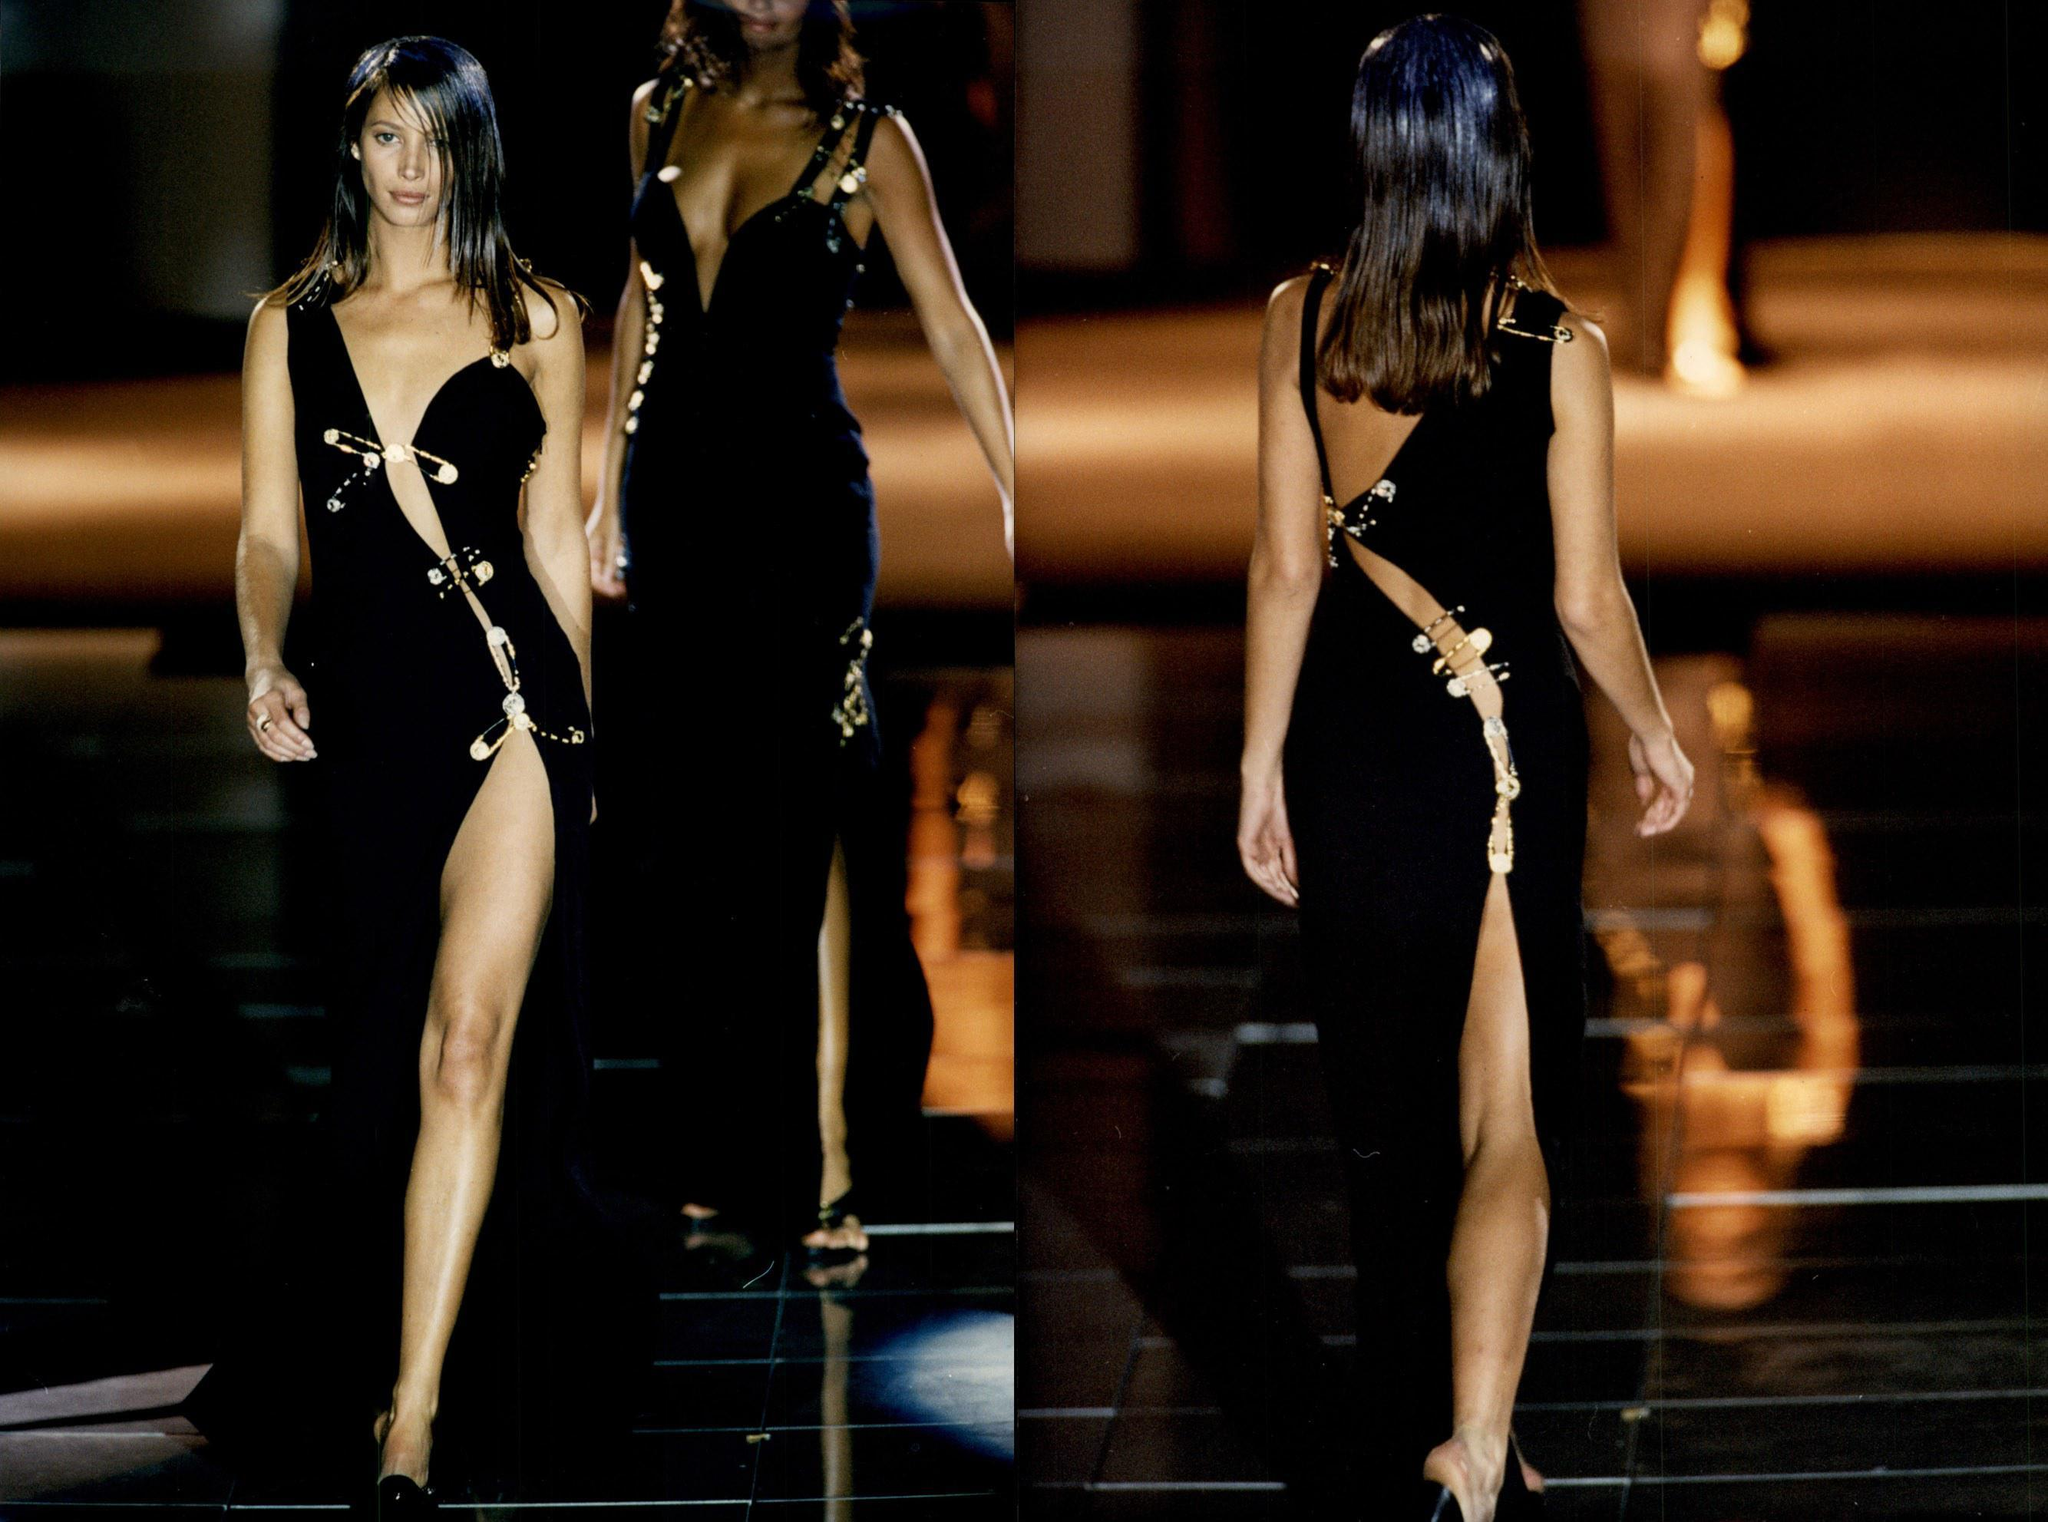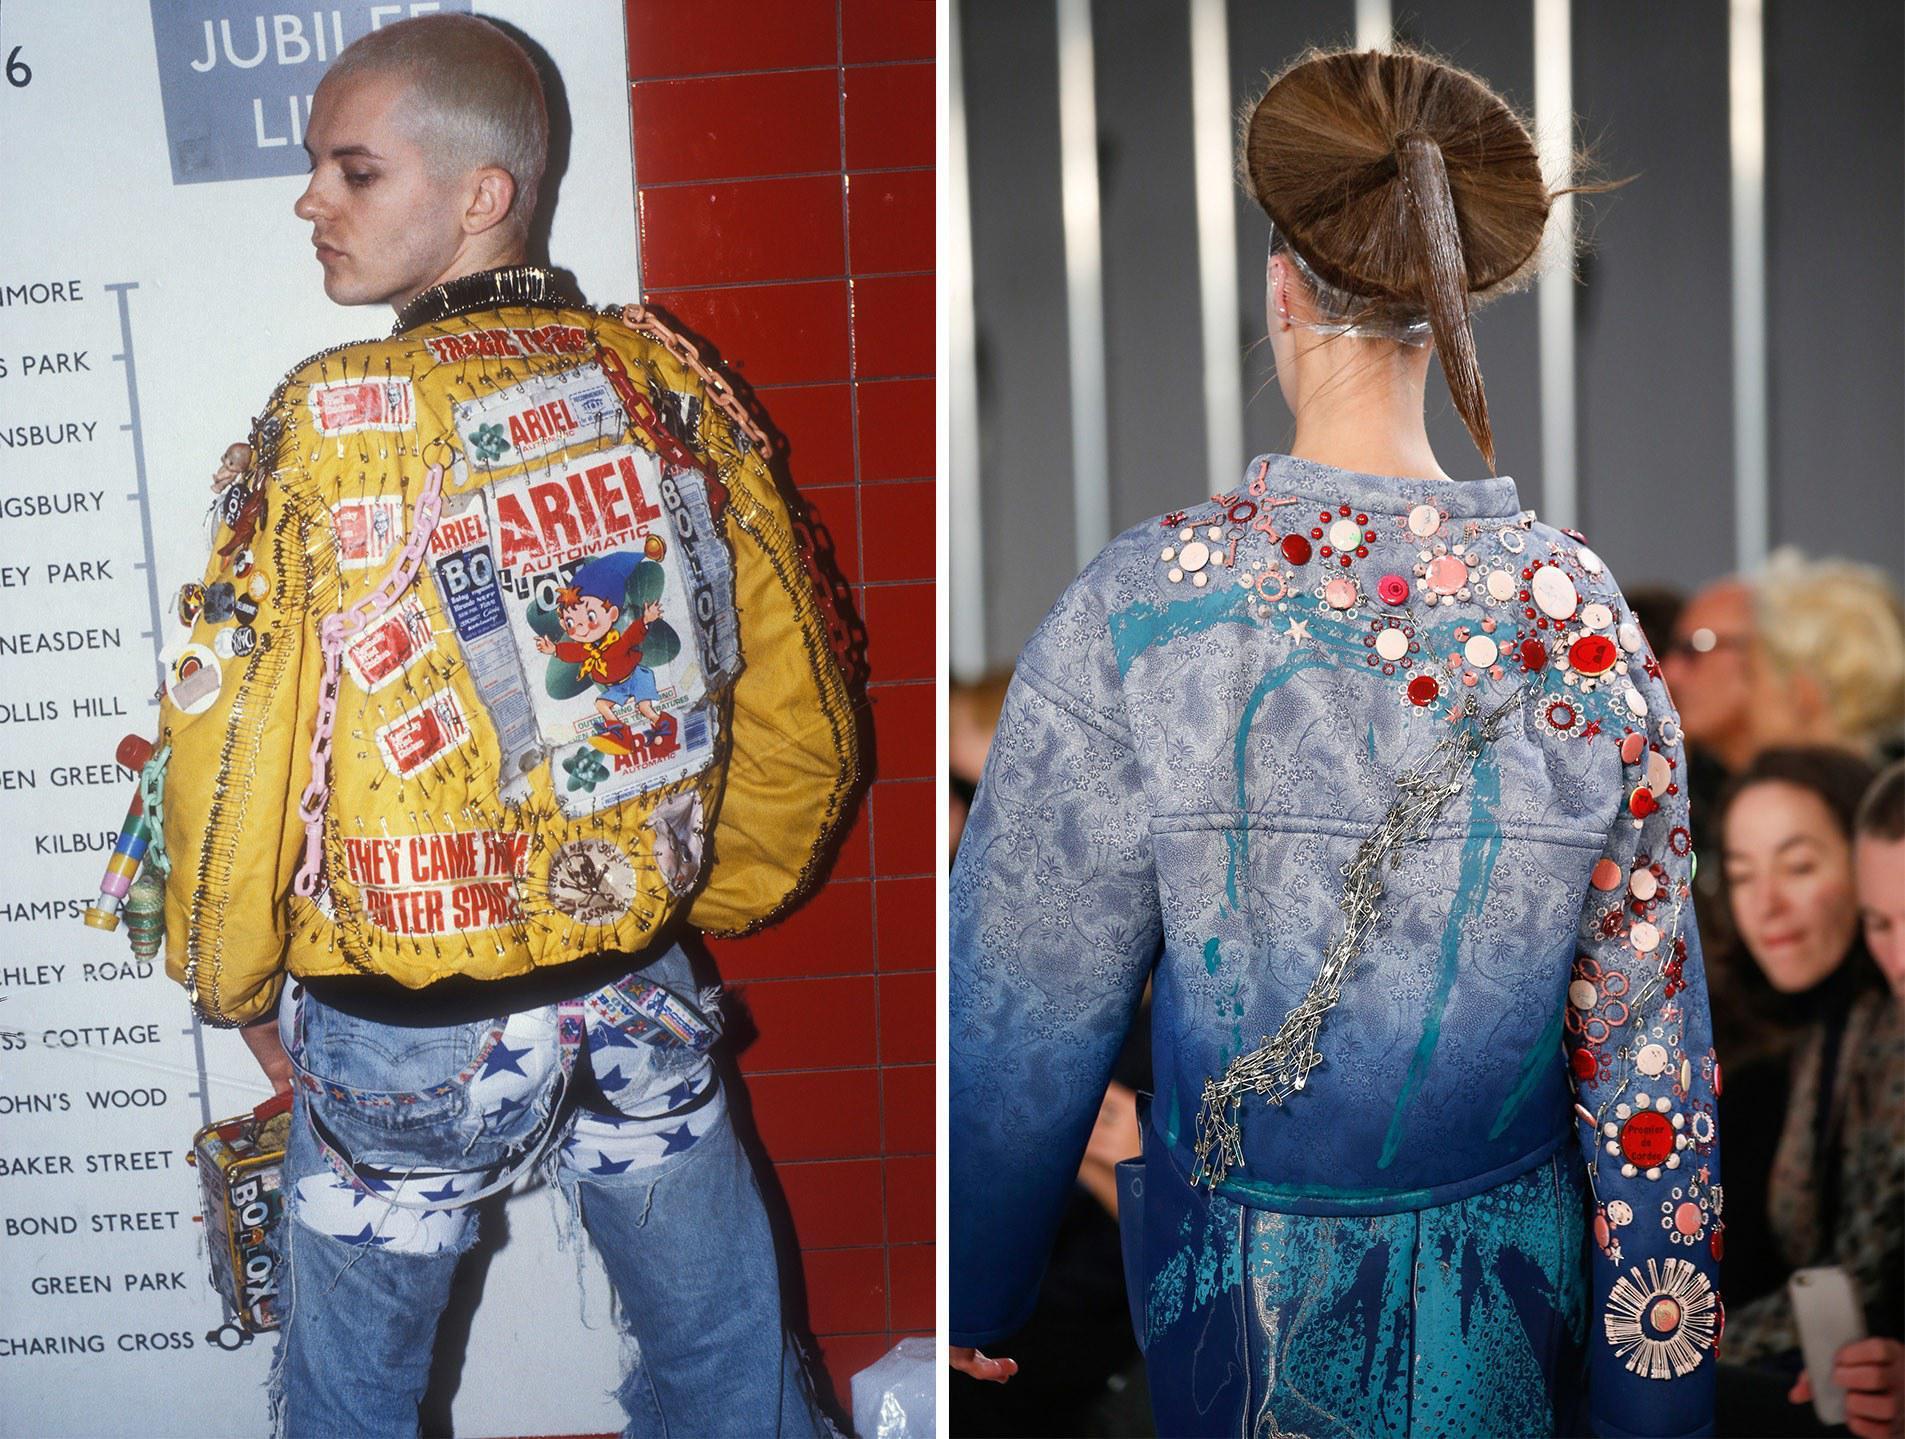The first image is the image on the left, the second image is the image on the right. For the images displayed, is the sentence "You cannot see the face of at least one of the models." factually correct? Answer yes or no. Yes. The first image is the image on the left, the second image is the image on the right. For the images displayed, is the sentence "At least one front view and one back view of fashions are shown by models." factually correct? Answer yes or no. Yes. 